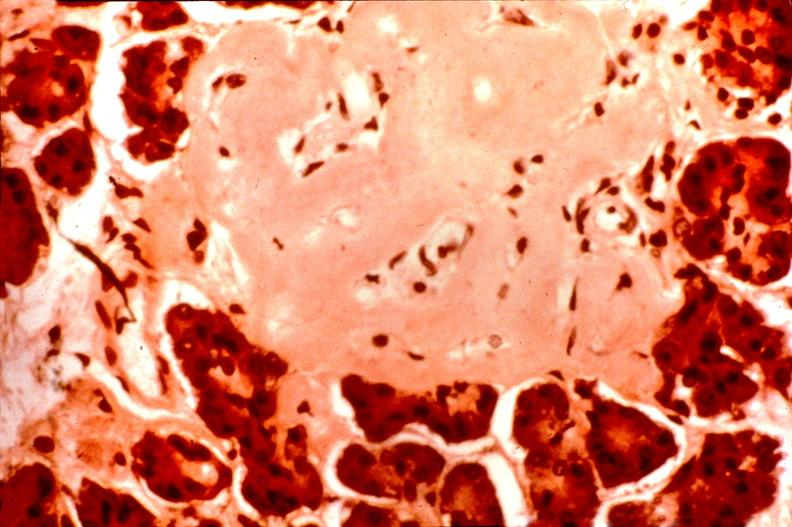does this image show pancrease, islet amyloid, diabetes mellitus?
Answer the question using a single word or phrase. Yes 